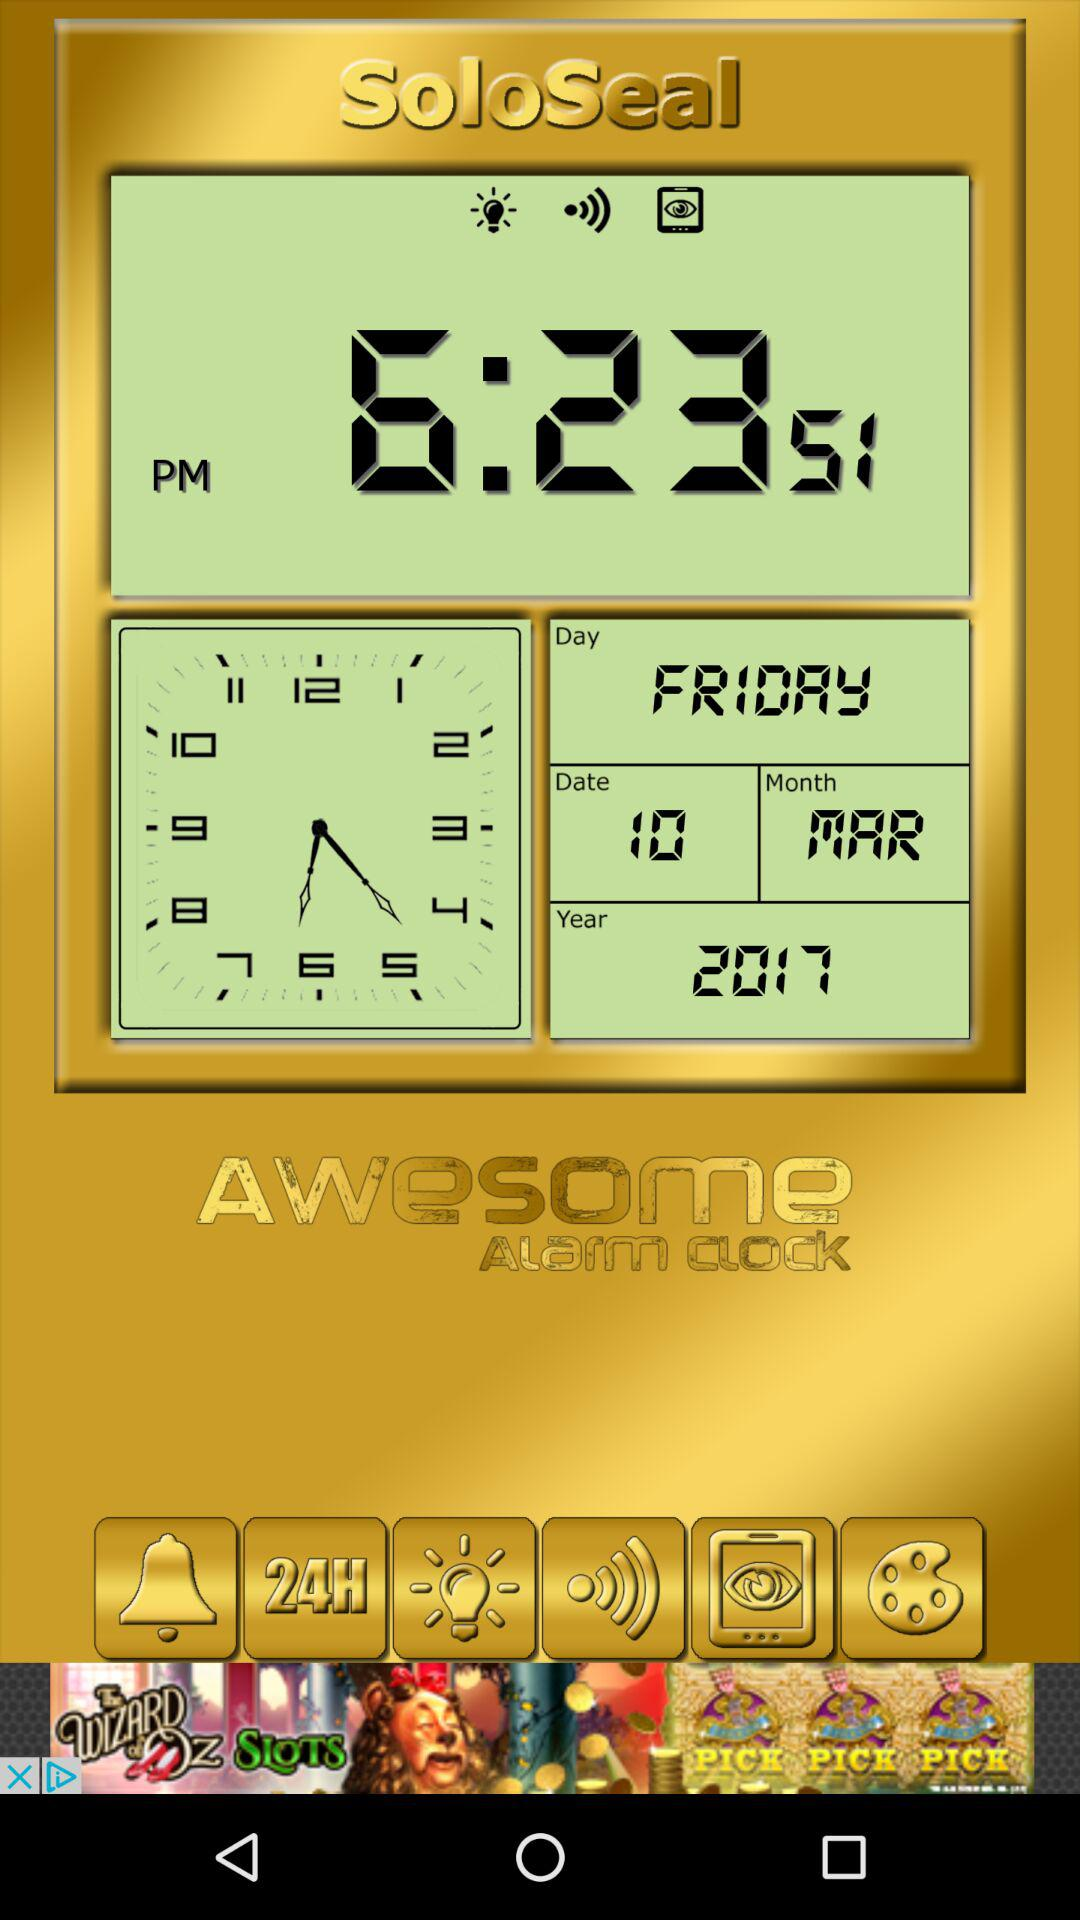What is the time displayed on the clock? The time displayed on the clock is 6:23:51 PM. 